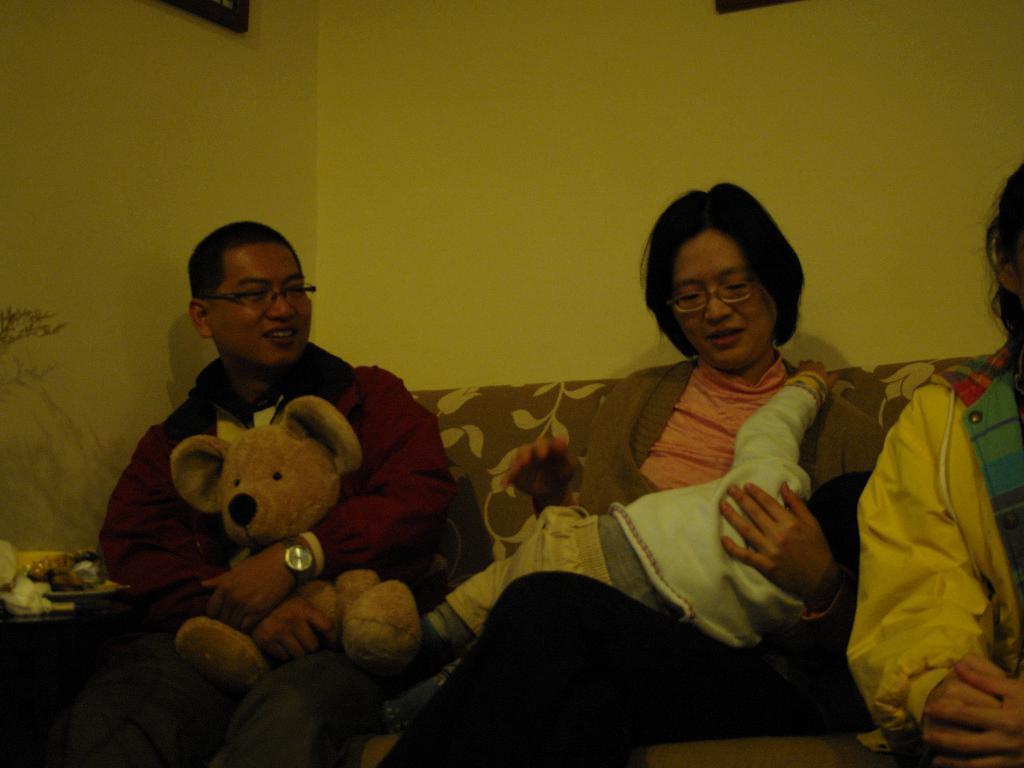Describe this image in one or two sentences. In this image we can see a man and a woman sitting on the sofa. There is a baby on the lap of the woman. The man is holding a teddy bear in his hand. There is one more person on the right side of the image. In the background, we can see the wall. At the top of the image, we can see frames. On the left side of the image, we can see a table and some objects. 